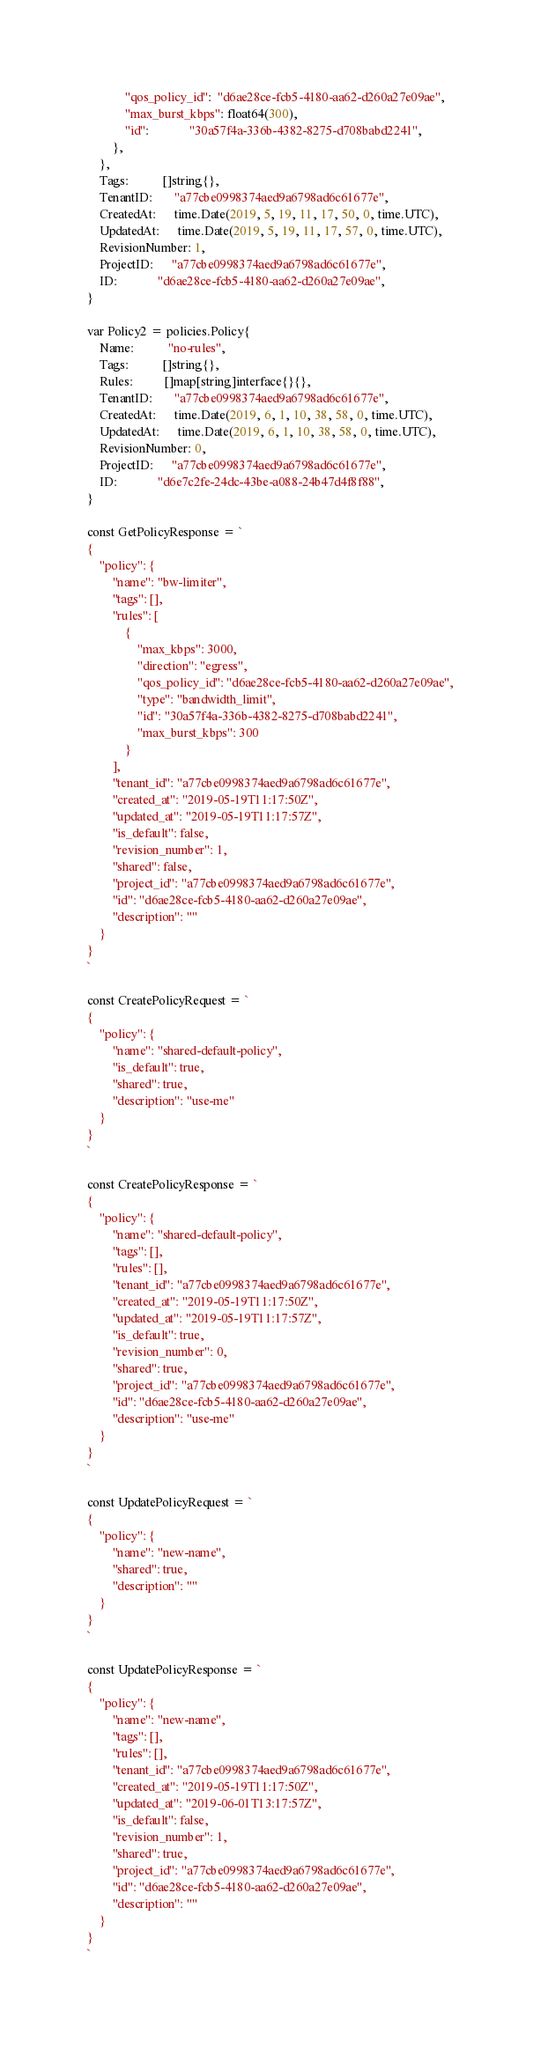<code> <loc_0><loc_0><loc_500><loc_500><_Go_>			"qos_policy_id":  "d6ae28ce-fcb5-4180-aa62-d260a27e09ae",
			"max_burst_kbps": float64(300),
			"id":             "30a57f4a-336b-4382-8275-d708babd2241",
		},
	},
	Tags:           []string{},
	TenantID:       "a77cbe0998374aed9a6798ad6c61677e",
	CreatedAt:      time.Date(2019, 5, 19, 11, 17, 50, 0, time.UTC),
	UpdatedAt:      time.Date(2019, 5, 19, 11, 17, 57, 0, time.UTC),
	RevisionNumber: 1,
	ProjectID:      "a77cbe0998374aed9a6798ad6c61677e",
	ID:             "d6ae28ce-fcb5-4180-aa62-d260a27e09ae",
}

var Policy2 = policies.Policy{
	Name:           "no-rules",
	Tags:           []string{},
	Rules:          []map[string]interface{}{},
	TenantID:       "a77cbe0998374aed9a6798ad6c61677e",
	CreatedAt:      time.Date(2019, 6, 1, 10, 38, 58, 0, time.UTC),
	UpdatedAt:      time.Date(2019, 6, 1, 10, 38, 58, 0, time.UTC),
	RevisionNumber: 0,
	ProjectID:      "a77cbe0998374aed9a6798ad6c61677e",
	ID:             "d6e7c2fe-24dc-43be-a088-24b47d4f8f88",
}

const GetPolicyResponse = `
{
    "policy": {
        "name": "bw-limiter",
        "tags": [],
        "rules": [
            {
                "max_kbps": 3000,
                "direction": "egress",
                "qos_policy_id": "d6ae28ce-fcb5-4180-aa62-d260a27e09ae",
                "type": "bandwidth_limit",
                "id": "30a57f4a-336b-4382-8275-d708babd2241",
                "max_burst_kbps": 300
            }
        ],
        "tenant_id": "a77cbe0998374aed9a6798ad6c61677e",
        "created_at": "2019-05-19T11:17:50Z",
        "updated_at": "2019-05-19T11:17:57Z",
        "is_default": false,
        "revision_number": 1,
        "shared": false,
        "project_id": "a77cbe0998374aed9a6798ad6c61677e",
        "id": "d6ae28ce-fcb5-4180-aa62-d260a27e09ae",
        "description": ""
    }
}
`

const CreatePolicyRequest = `
{
    "policy": {
        "name": "shared-default-policy",
        "is_default": true,
        "shared": true,
        "description": "use-me"
    }
}
`

const CreatePolicyResponse = `
{
    "policy": {
        "name": "shared-default-policy",
        "tags": [],
        "rules": [],
        "tenant_id": "a77cbe0998374aed9a6798ad6c61677e",
        "created_at": "2019-05-19T11:17:50Z",
        "updated_at": "2019-05-19T11:17:57Z",
        "is_default": true,
        "revision_number": 0,
        "shared": true,
        "project_id": "a77cbe0998374aed9a6798ad6c61677e",
        "id": "d6ae28ce-fcb5-4180-aa62-d260a27e09ae",
        "description": "use-me"
    }
}
`

const UpdatePolicyRequest = `
{
    "policy": {
        "name": "new-name",
        "shared": true,
        "description": ""
    }
}
`

const UpdatePolicyResponse = `
{
    "policy": {
        "name": "new-name",
        "tags": [],
        "rules": [],
        "tenant_id": "a77cbe0998374aed9a6798ad6c61677e",
        "created_at": "2019-05-19T11:17:50Z",
        "updated_at": "2019-06-01T13:17:57Z",
        "is_default": false,
        "revision_number": 1,
        "shared": true,
        "project_id": "a77cbe0998374aed9a6798ad6c61677e",
        "id": "d6ae28ce-fcb5-4180-aa62-d260a27e09ae",
        "description": ""
    }
}
`
</code> 